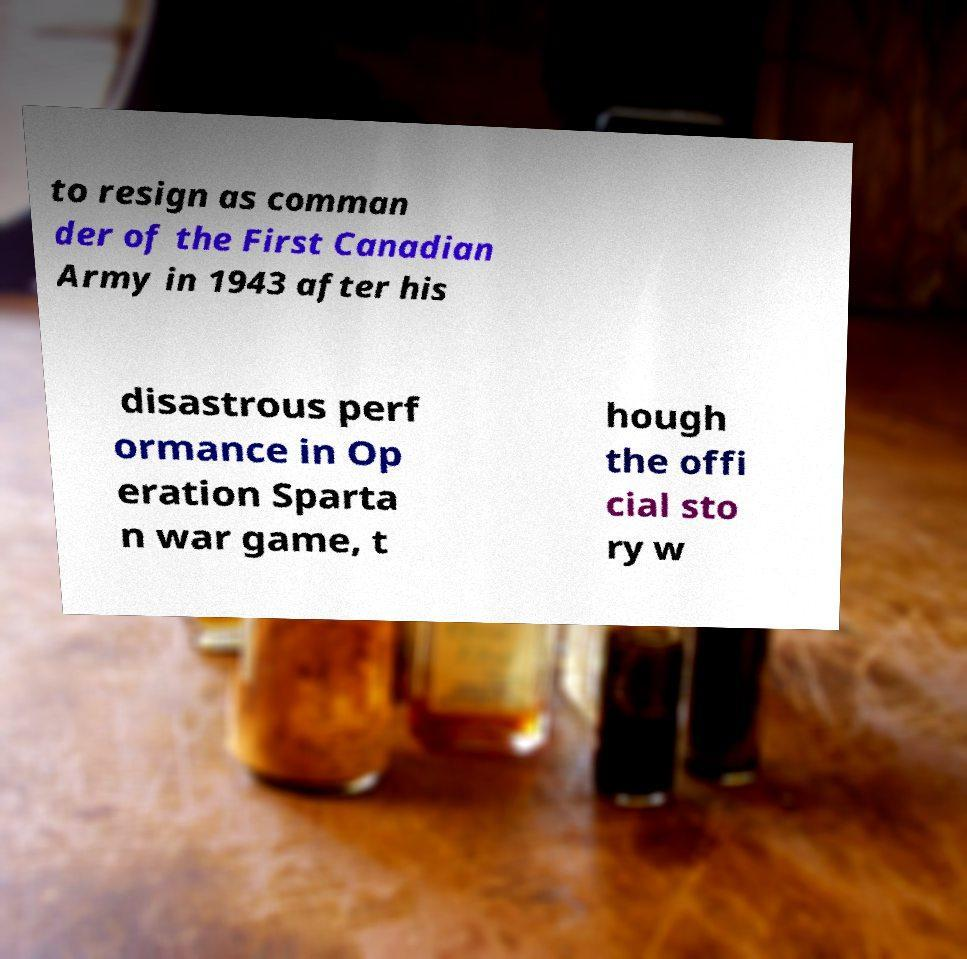Could you extract and type out the text from this image? to resign as comman der of the First Canadian Army in 1943 after his disastrous perf ormance in Op eration Sparta n war game, t hough the offi cial sto ry w 